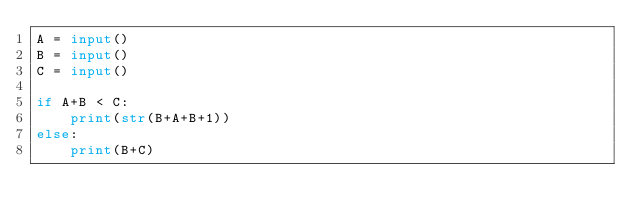Convert code to text. <code><loc_0><loc_0><loc_500><loc_500><_Python_>A = input()
B = input()
C = input()

if A+B < C:
    print(str(B+A+B+1))
else:
    print(B+C)</code> 